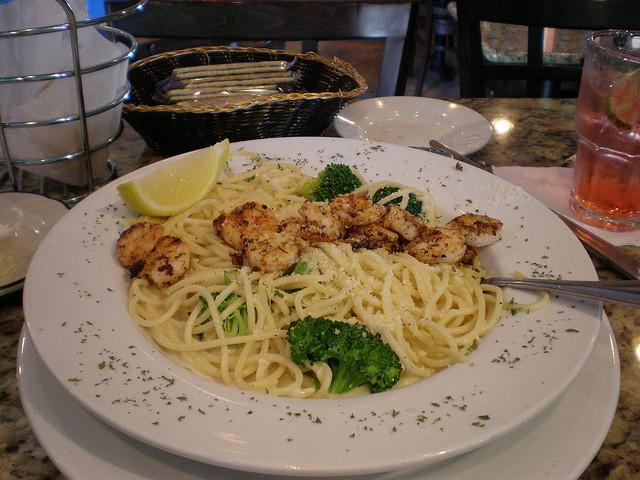What is in the spaghetti? Please explain your reasoning. shrimp. Seafood and pasta is often served together. 